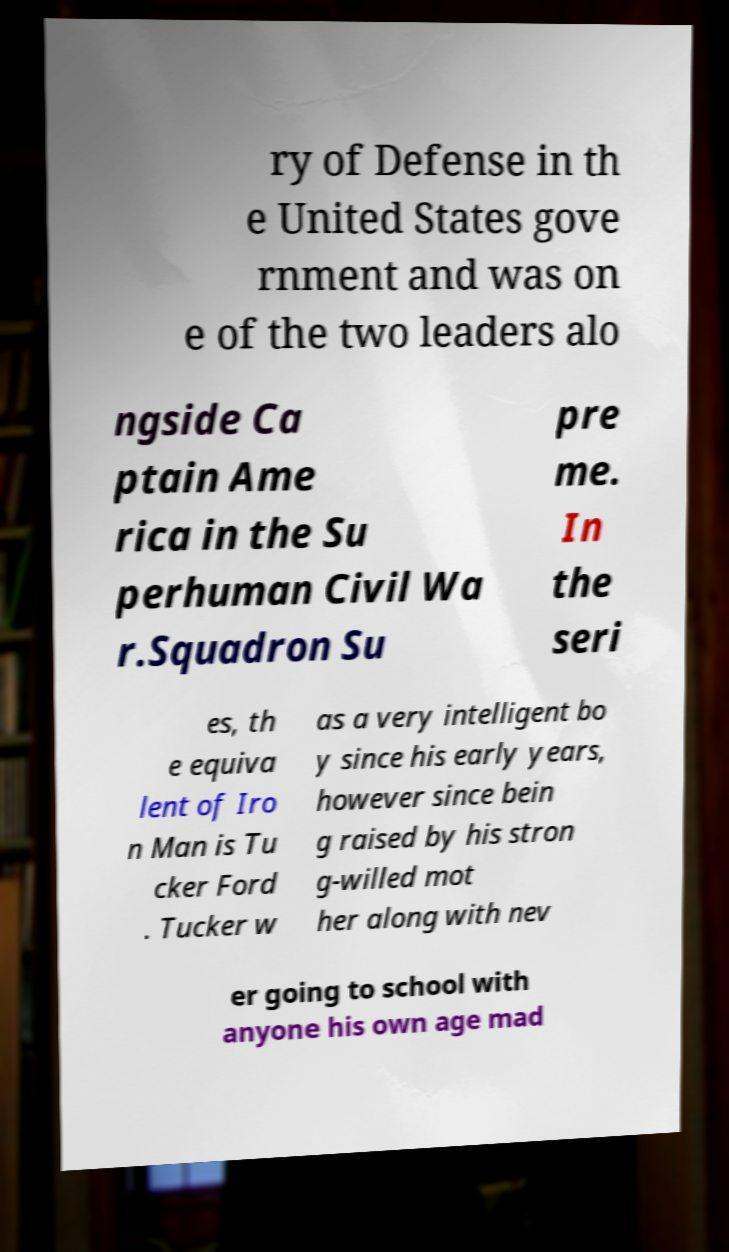I need the written content from this picture converted into text. Can you do that? ry of Defense in th e United States gove rnment and was on e of the two leaders alo ngside Ca ptain Ame rica in the Su perhuman Civil Wa r.Squadron Su pre me. In the seri es, th e equiva lent of Iro n Man is Tu cker Ford . Tucker w as a very intelligent bo y since his early years, however since bein g raised by his stron g-willed mot her along with nev er going to school with anyone his own age mad 